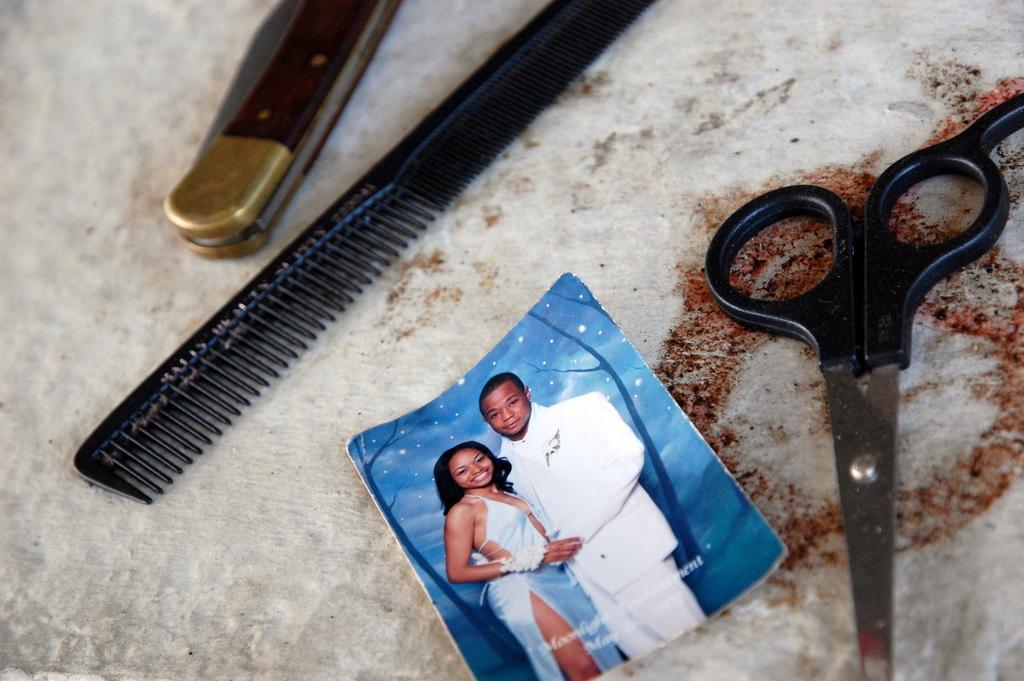In one or two sentences, can you explain what this image depicts? In this image I see a black comb, a scissor and a photo of a man and a woman and I see that both of them are smiling and I see a thing over here and these all things are on a white surface and it is a bit red over here. 